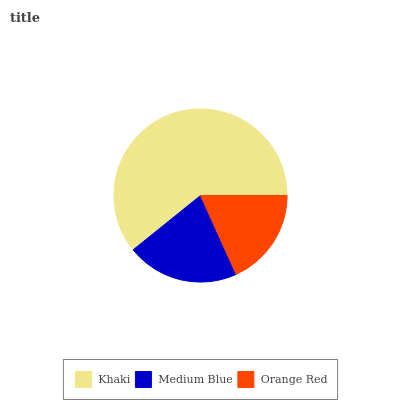Is Orange Red the minimum?
Answer yes or no. Yes. Is Khaki the maximum?
Answer yes or no. Yes. Is Medium Blue the minimum?
Answer yes or no. No. Is Medium Blue the maximum?
Answer yes or no. No. Is Khaki greater than Medium Blue?
Answer yes or no. Yes. Is Medium Blue less than Khaki?
Answer yes or no. Yes. Is Medium Blue greater than Khaki?
Answer yes or no. No. Is Khaki less than Medium Blue?
Answer yes or no. No. Is Medium Blue the high median?
Answer yes or no. Yes. Is Medium Blue the low median?
Answer yes or no. Yes. Is Orange Red the high median?
Answer yes or no. No. Is Khaki the low median?
Answer yes or no. No. 